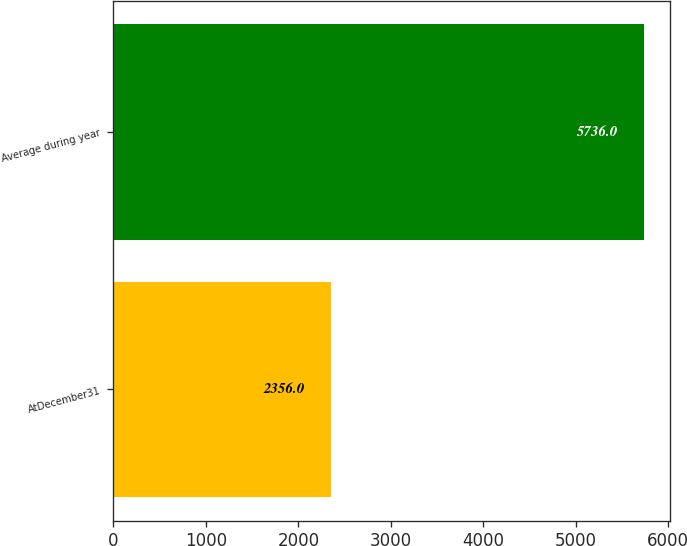<chart> <loc_0><loc_0><loc_500><loc_500><bar_chart><fcel>AtDecember31<fcel>Average during year<nl><fcel>2356<fcel>5736<nl></chart> 